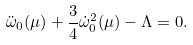Convert formula to latex. <formula><loc_0><loc_0><loc_500><loc_500>\ddot { \omega } _ { 0 } ( \mu ) + \frac { 3 } { 4 } \dot { \omega } ^ { 2 } _ { 0 } ( \mu ) - \Lambda = 0 .</formula> 